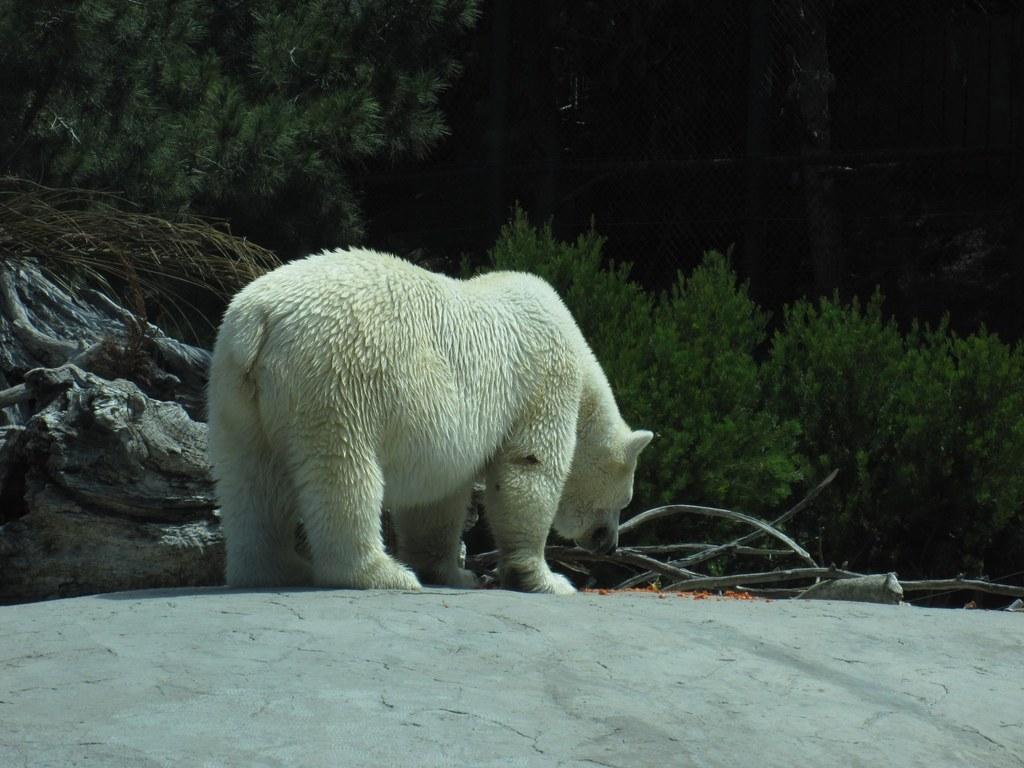In one or two sentences, can you explain what this image depicts? In this image there is a polar bear standing on the ground. In front of it there are dried stems and rocks. In the background there are plants. At the top it is dark. 